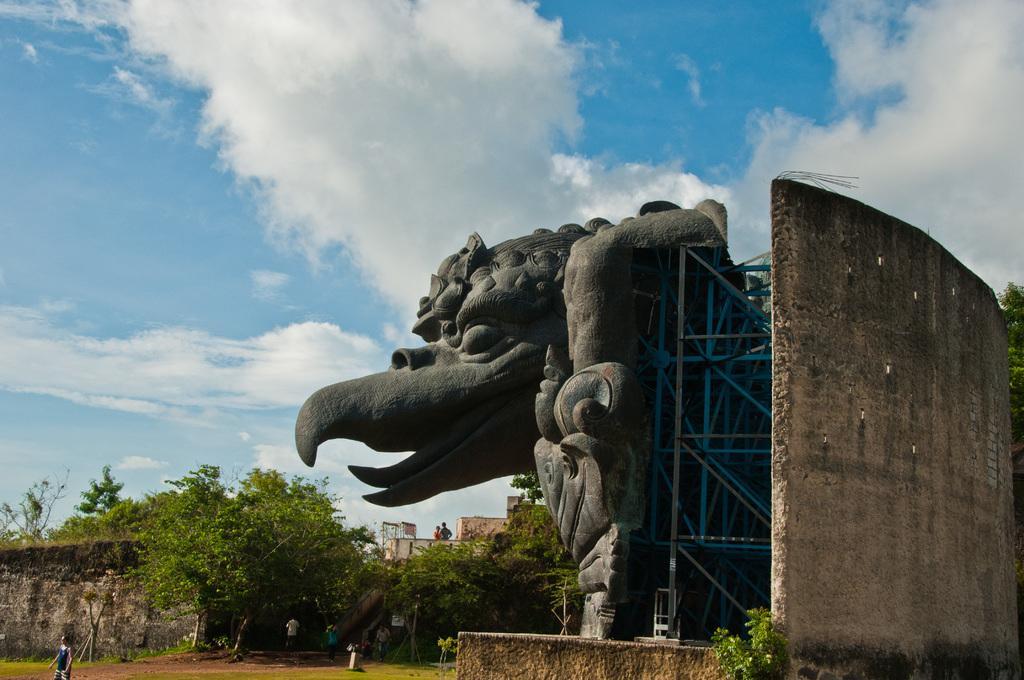Could you give a brief overview of what you see in this image? In this image we can see a statue, group of trees, poles and a group of persons standing on the ground. In the background, we can see the cloudy sky. 